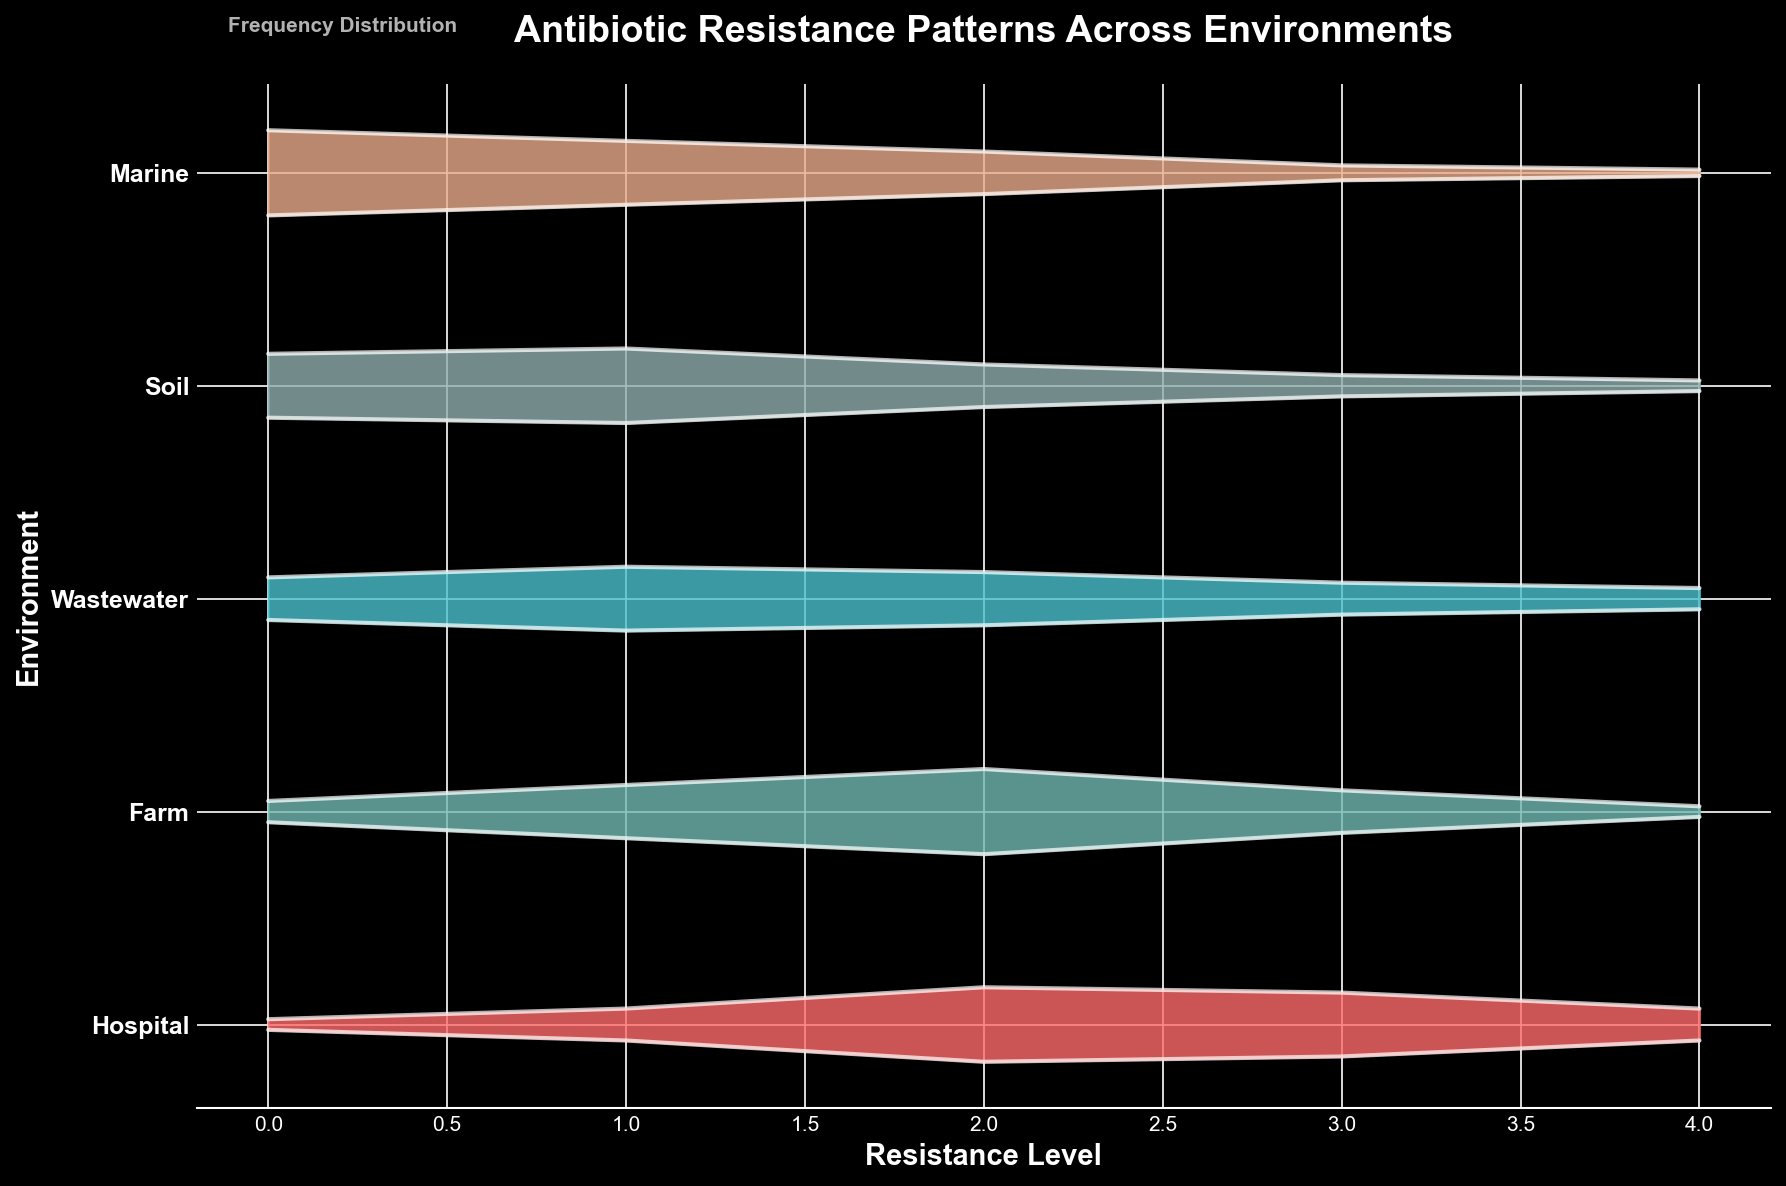What's the title of the figure? The title of the figure is displayed at the top center of the plot. By looking at the title, one can know the overall topic that the plot is trying to convey. The title in this figure is "Antibiotic Resistance Patterns Across Environments"
Answer: Antibiotic Resistance Patterns Across Environments How many unique environments are represented in the plot? The y-axis of the plot lists each unique environment. Counting the number of categories shown on the y-axis will give the number of unique environments. There are five environments listed: Hospital, Farm, Wastewater, Soil, and Marine
Answer: 5 Which environment exhibits the highest frequency of the lowest resistance level (0)? By observing the heights of the peaks at Resistance Level 0 for each environment, we see that the Marine environment has the tallest peak at this level, indicating the highest frequency.
Answer: Marine In which environment does the antibiotic resistance appear to be most evenly distributed across all resistance levels? By comparing the shape and height of the plots for each environment, Soil exhibits distributions that are more similar in height across all resistance levels, indicating a more even distribution
Answer: Soil Which environment shows the highest resistance level most frequently? Determine the highest peaks at Resistance Level 4 across all environments. The Hospital environment has the highest frequency at this resistance level, shown by the taller peak
Answer: Hospital Is there any environment where the frequency of Resistance Level 2 is higher than 0.4? The peaks for Resistance Level 2 in all environments do not reach above 0.4. The highest frequency for Level 2 in any environment is 0.4, specifically in the Farm environment
Answer: No Which environment shows the highest overall frequency for Resistance Level 1? We need to compare the heights of the peaks at Resistance Level 1 for each environment. The Soil environment has the highest peak at Resistance Level 1
Answer: Soil Compare the frequency of Resistance Level 3 in the Hospital and Wastewater environments. Which one is higher? Looking at the plot for the peaks at Resistance Level 3, Hospital has a higher frequency peak compared to Wastewater
Answer: Hospital Which antibiotic has the most uneven distribution of resistance levels? The shape of the ridgeline for each antibiotic indicates how uneven the distribution is. Methicillin in the Hospital environment shows a more varied distribution with high peaks and low troughs, indicating greater unevenness
Answer: Methicillin How does the distribution of resistance levels in the Marine environment compare to those in the Soil environment in terms of overall slope? The Marine environment shows a steep decline from low to high resistance levels, while the Soil environment has a more gradual decline, indicating a gentler slope
Answer: Marine has a steeper slope 